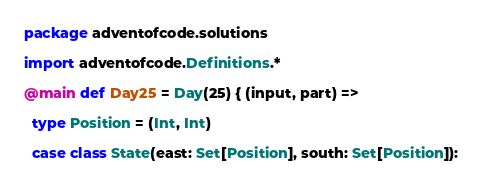<code> <loc_0><loc_0><loc_500><loc_500><_Scala_>package adventofcode.solutions

import adventofcode.Definitions.*

@main def Day25 = Day(25) { (input, part) =>

  type Position = (Int, Int)

  case class State(east: Set[Position], south: Set[Position]):</code> 